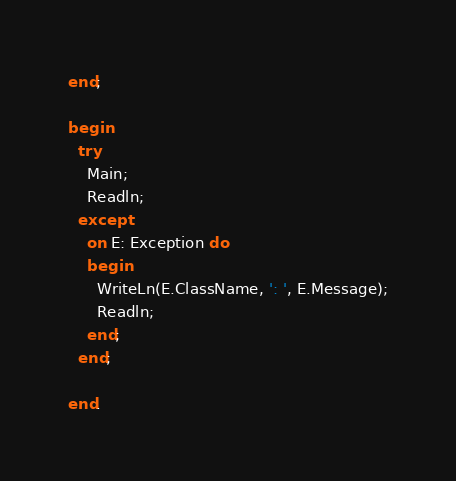Convert code to text. <code><loc_0><loc_0><loc_500><loc_500><_Pascal_>end;

begin
  try
    Main;
    Readln;
  except
    on E: Exception do
    begin
      WriteLn(E.ClassName, ': ', E.Message);
      Readln;
    end;
  end;

end.
</code> 